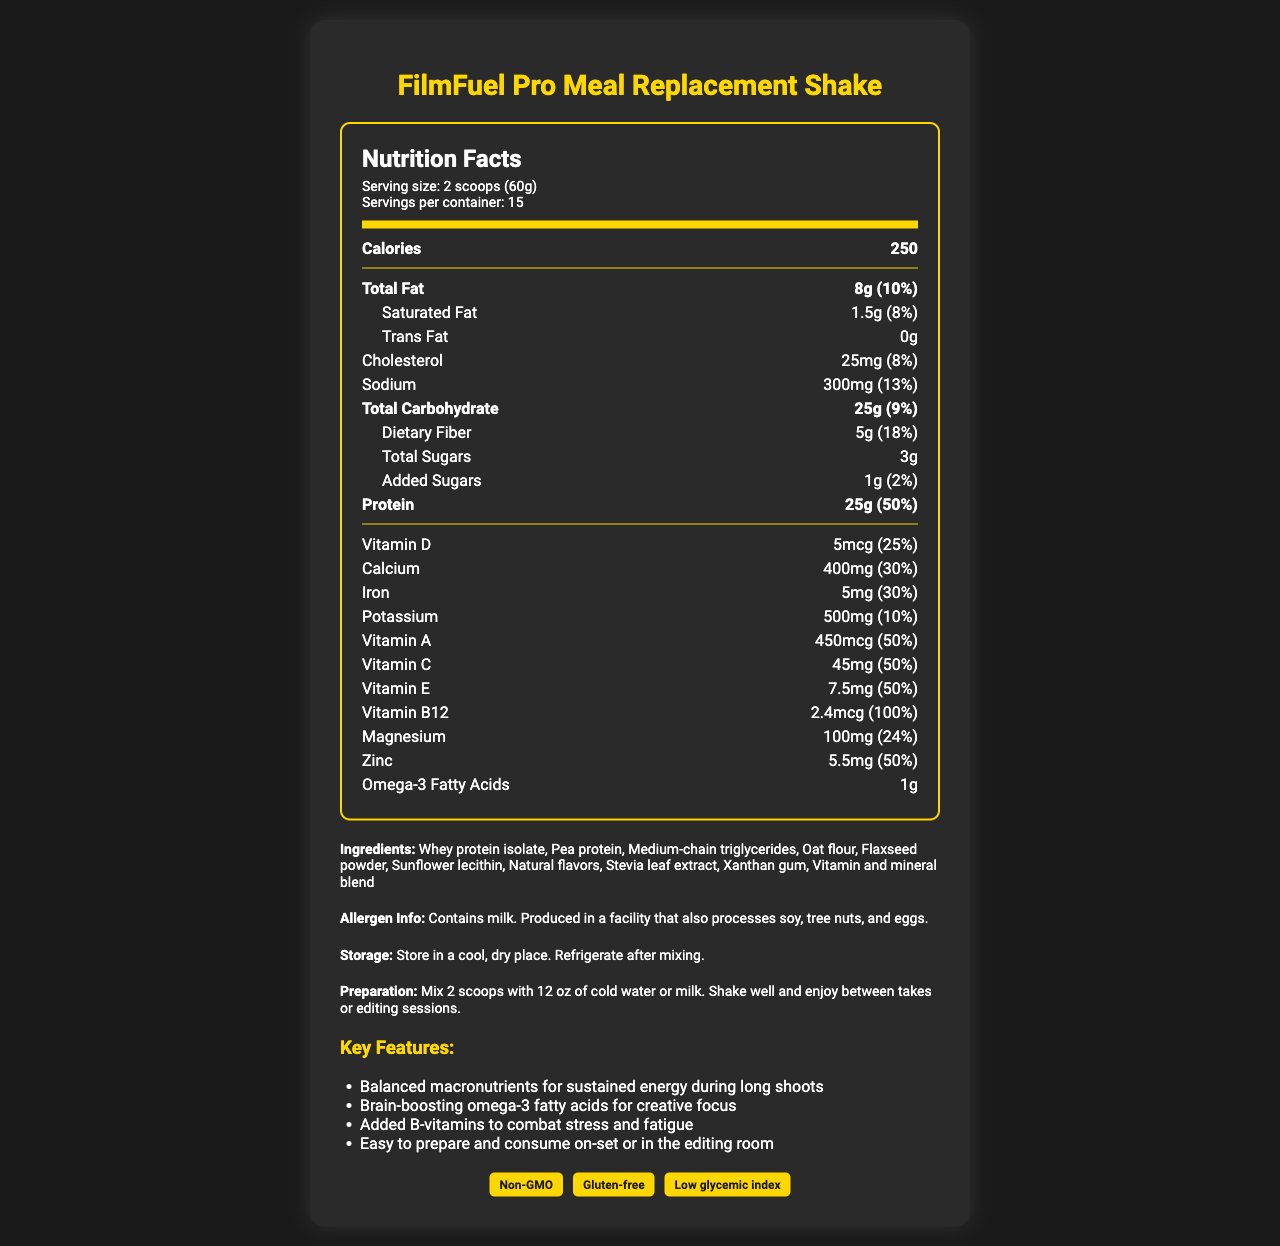what is the serving size of FilmFuel Pro Meal Replacement Shake? The serving size is explicitly listed as "2 scoops (60g)" in the serving information section.
Answer: 2 scoops (60g) how many calories are in one serving of the shake? The document clearly states that each serving contains 250 calories.
Answer: 250 how much protein does one serving of the shake provide? The document lists the protein content as 25g per serving.
Answer: 25g what is the daily value percentage of sodium per serving? It is explicitly mentioned that the sodium daily value percentage per serving is 13%.
Answer: 13% how much iron does one serving contain? The iron content per serving is indicated as 5mg.
Answer: 5mg how many servings are in one container? A. 10 B. 15 C. 20 D. 25 The document specifies that there are 15 servings per container.
Answer: B what is the daily value percentage of Vitamin B12 in one serving? A. 25% B. 50% C. 100% D. 75% The daily value percentage of Vitamin B12 is listed as 100%.
Answer: C does the shake contain any trans fat? It is mentioned that there is 0g of trans fat in the shake.
Answer: No are there any certifications listed for the shake? The document shows that the shake has certifications such as Non-GMO, Gluten-free, and Low glycemic index.
Answer: Yes describe the main idea of the document. The document provides comprehensive nutritional information, ingredients, allergen info, preparation and storage instructions, key features, and certifications.
Answer: It's a detailed Nutrition Facts Label for the FilmFuel Pro Meal Replacement Shake. what is the omega-3 fatty acids content in the shake? The document lists the omega-3 fatty acids content as 1g.
Answer: 1g which ingredient is used for natural sweetening in the shake? The ingredients list includes "Stevia leaf extract" as the natural sweetener.
Answer: Stevia leaf extract what kind of dietary fiber is provided, soluble or insoluble? The document does not specify whether the dietary fiber is soluble or insoluble.
Answer: Cannot be determined does the product contain milk as an allergen? The allergen info mentions "Contains milk."
Answer: Yes how is the shake to be prepared? The preparation instructions provided in the document outline these steps.
Answer: Mix 2 scoops with 12 oz of cold water or milk. Shake well and enjoy between takes or editing sessions. 